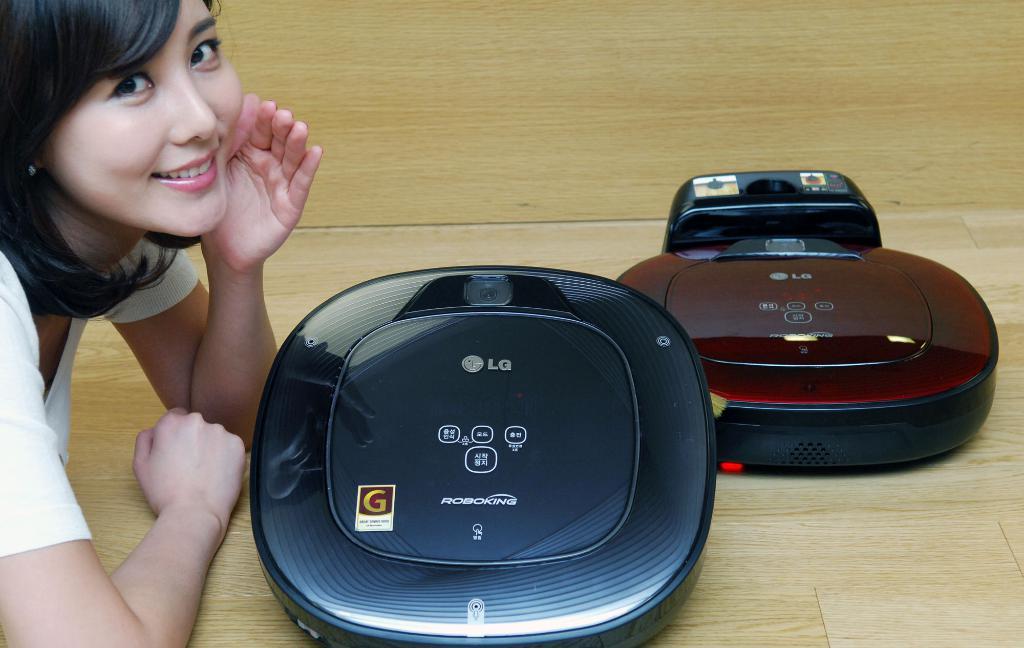What is the model name of this appliance?
Offer a very short reply. Lg. 